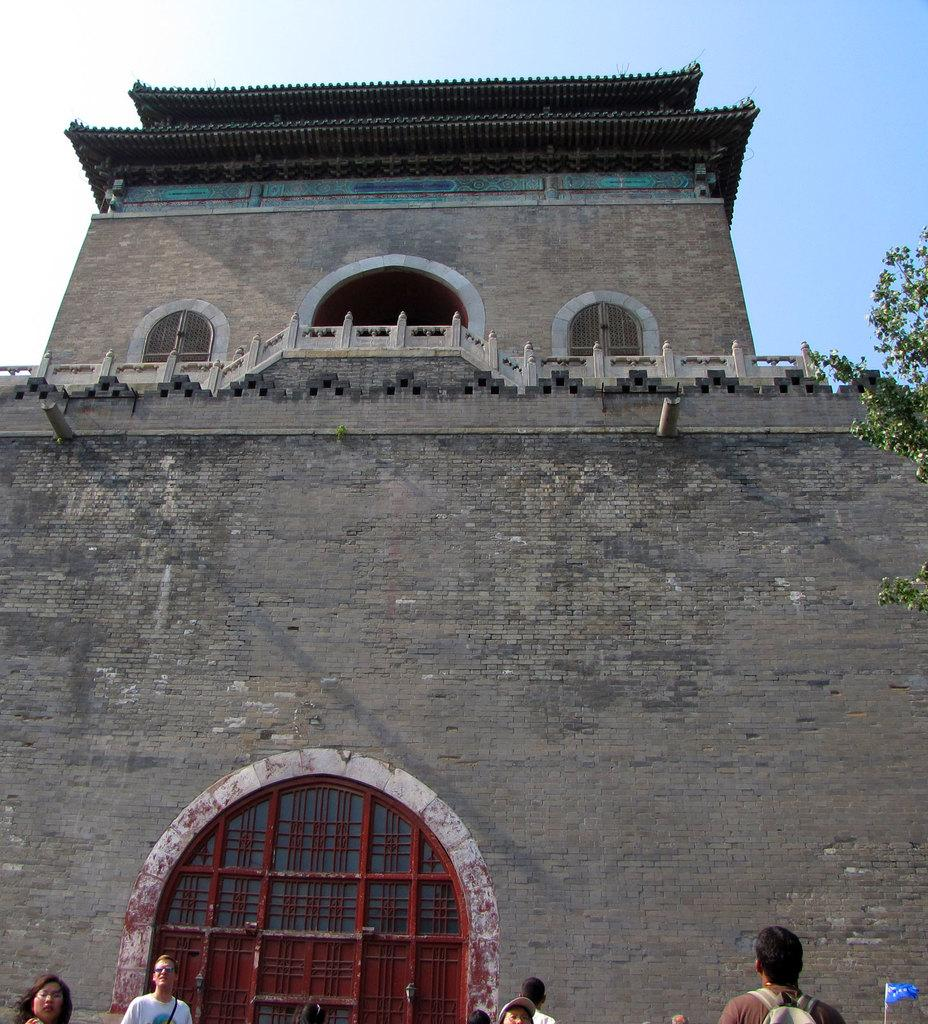What type of structure is visible in the image? There is a building with windows in the image. What can be seen in front of the building? There are people and a tree in front of the building. What is attached to the building in the image? There is a flag in front of the building. What is visible in the background of the image? The sky is visible in the background of the image. What is the car's desire in the image? There is no car present in the image, so it is not possible to determine its desires. 